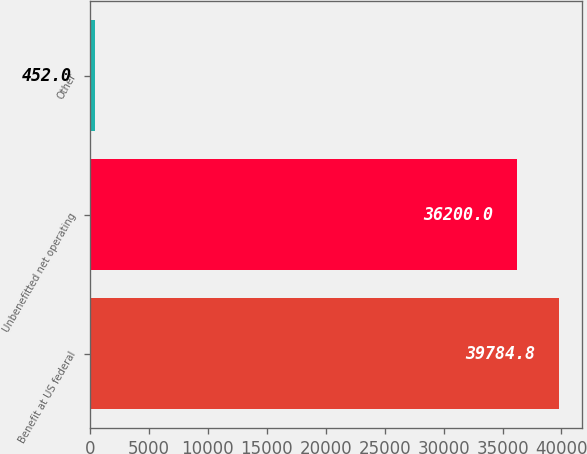Convert chart. <chart><loc_0><loc_0><loc_500><loc_500><bar_chart><fcel>Benefit at US federal<fcel>Unbenefitted net operating<fcel>Other<nl><fcel>39784.8<fcel>36200<fcel>452<nl></chart> 